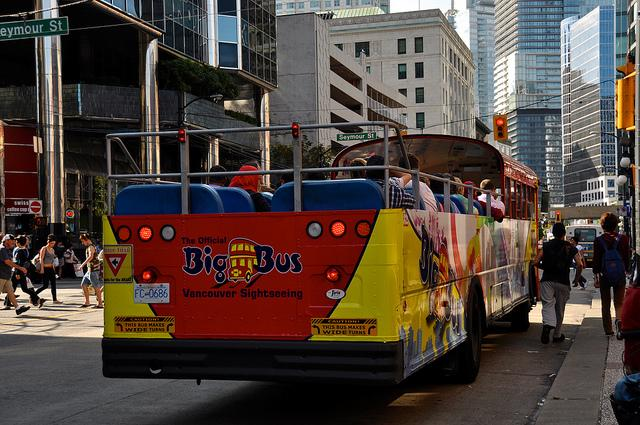What type of company owns the roofless bus? sightseeing 